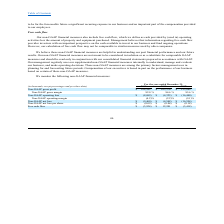According to Mobileiron's financial document, What is free cash flow? cash provided by (used in) operating activities less the amount of property and equipment purchased. The document states: "s also include free cash flow, which we define as cash provided by (used in) operating activities less the amount of property and equipment purchased...." Also, How does management use non-GAAP measures? The document shows two values: planning for and forecasting future periods and understand, manage and evaluate our business, and make operating decisions. From the document: "emental non-GAAP financial measures internally to understand, manage and evaluate our business, and make operating decisions. These non-GAAP measures ..." Also, What does information about free cash flow provide investors with? an important perspective on the cash available to invest in our business and fund ongoing operations. The document states: "regarding free cash flow provides investors with an important perspective on the cash available to invest in our business and fund ongoing operations...." Also, can you calculate: What was the average non-GAAP gross profit for the 3 year period from 2017 to 2019? To answer this question, I need to perform calculations using the financial data. The calculation is: (168,242+163,376+153,849)/3, which equals 161822.33 (in thousands). This is based on the information: "Non-GAAP gross profit $ 168,242 $ 163,376 $ 153,849 Non-GAAP gross profit $ 168,242 $ 163,376 $ 153,849 Non-GAAP gross profit $ 168,242 $ 163,376 $ 153,849..." The key data points involved are: 153,849, 163,376, 168,242. Also, can you calculate: What was the % change in the free cash flow from 2017 to 2018? To answer this question, I need to perform calculations using the financial data. The calculation is: (12,201-(-3,418))/-3,418, which equals -456.96 (percentage). This is based on the information: "Free cash flow $ (3,924) $ 12,201 $ (3,418) Free cash flow $ (3,924) $ 12,201 $ (3,418)..." The key data points involved are: 12,201, 3,418. Also, can you calculate: What is the change in non-GAAP gross profit between 2017 and 2019, as a % of the total gross profit for 2018? To answer this question, I need to perform calculations using the financial data. The calculation is: (168,242-153,849)/163,376, which equals 8.81 (percentage). This is based on the information: "Non-GAAP gross profit $ 168,242 $ 163,376 $ 153,849 Non-GAAP gross profit $ 168,242 $ 163,376 $ 153,849 Non-GAAP gross profit $ 168,242 $ 163,376 $ 153,849..." The key data points involved are: 153,849, 163,376, 168,242. 